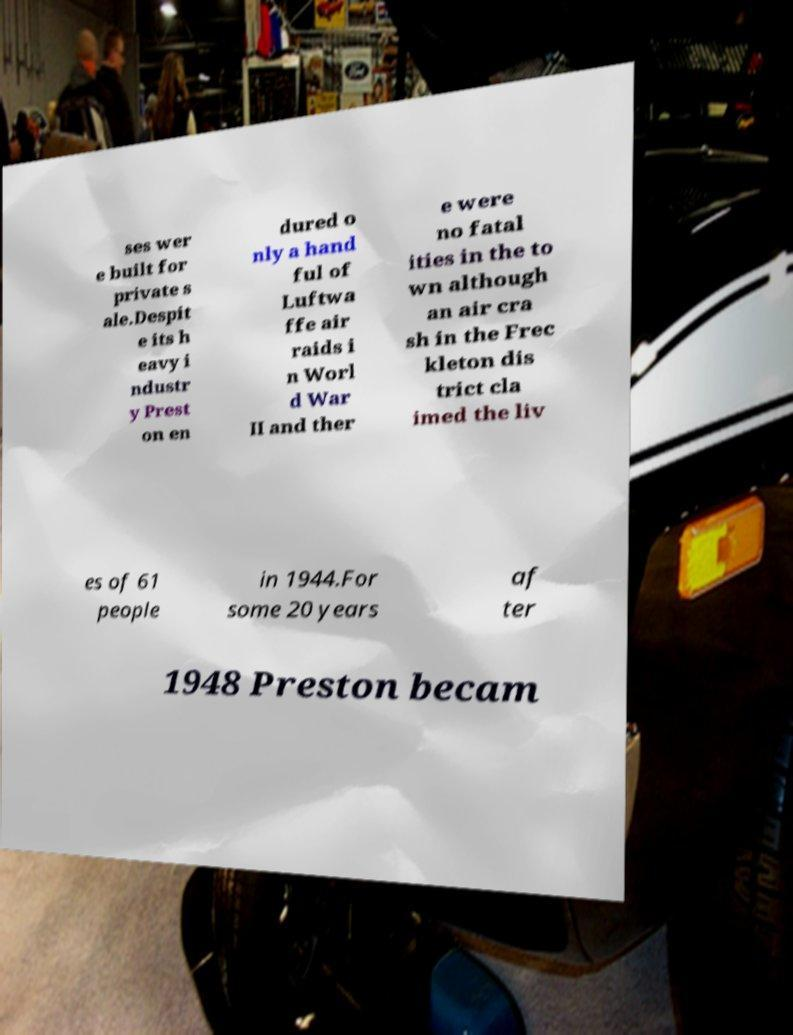Could you extract and type out the text from this image? ses wer e built for private s ale.Despit e its h eavy i ndustr y Prest on en dured o nly a hand ful of Luftwa ffe air raids i n Worl d War II and ther e were no fatal ities in the to wn although an air cra sh in the Frec kleton dis trict cla imed the liv es of 61 people in 1944.For some 20 years af ter 1948 Preston becam 